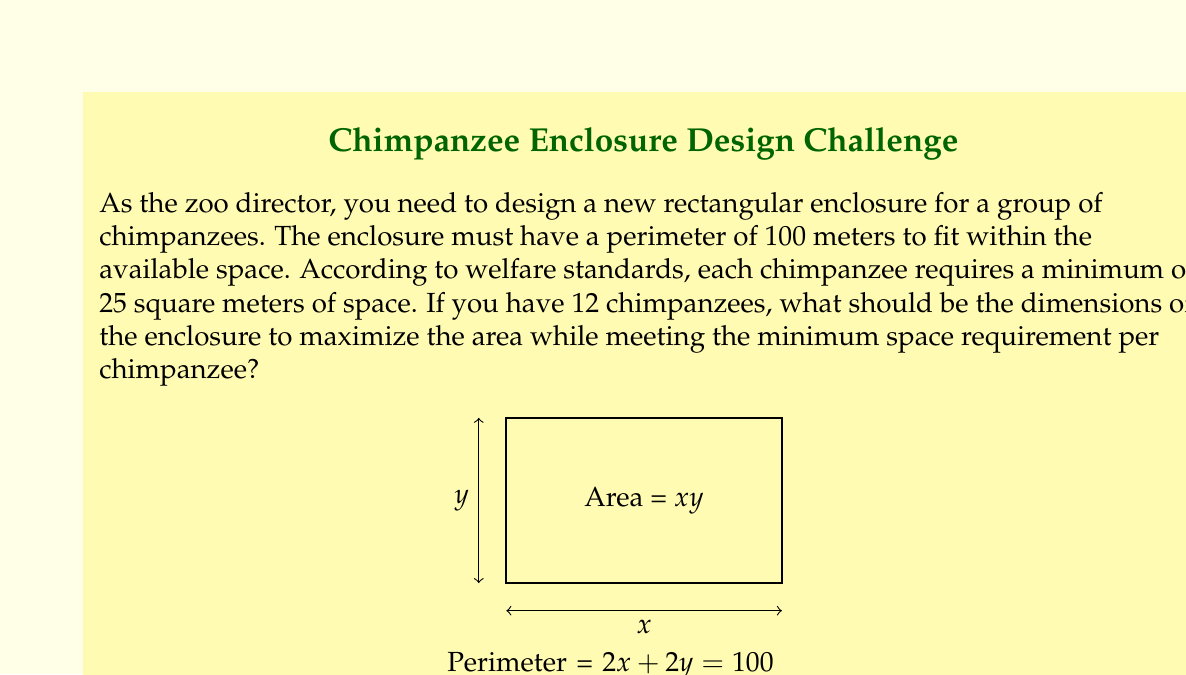Can you solve this math problem? Let's approach this step-by-step:

1) Let $x$ and $y$ be the length and width of the enclosure respectively.

2) Given that the perimeter is 100 meters:
   $$2x + 2y = 100$$
   $$x + y = 50$$

3) We need to maximize the area $A = xy$ subject to this constraint.

4) Express $y$ in terms of $x$:
   $$y = 50 - x$$

5) Now, the area function becomes:
   $$A(x) = x(50-x) = 50x - x^2$$

6) To find the maximum, differentiate $A(x)$ and set it to zero:
   $$\frac{dA}{dx} = 50 - 2x = 0$$
   $$2x = 50$$
   $$x = 25$$

7) This gives us $y = 50 - 25 = 25$ as well.

8) Check the second derivative to confirm it's a maximum:
   $$\frac{d^2A}{dx^2} = -2 < 0$$, confirming a maximum.

9) The maximum area is thus:
   $$A = 25 * 25 = 625 \text{ square meters}$$

10) Check if this meets the minimum space requirement:
    Required space = $12 * 25 = 300 \text{ square meters}$
    $625 \text{ m}^2 > 300 \text{ m}^2$, so the requirement is met.

Therefore, the optimal dimensions are 25 meters by 25 meters.
Answer: 25 m × 25 m 